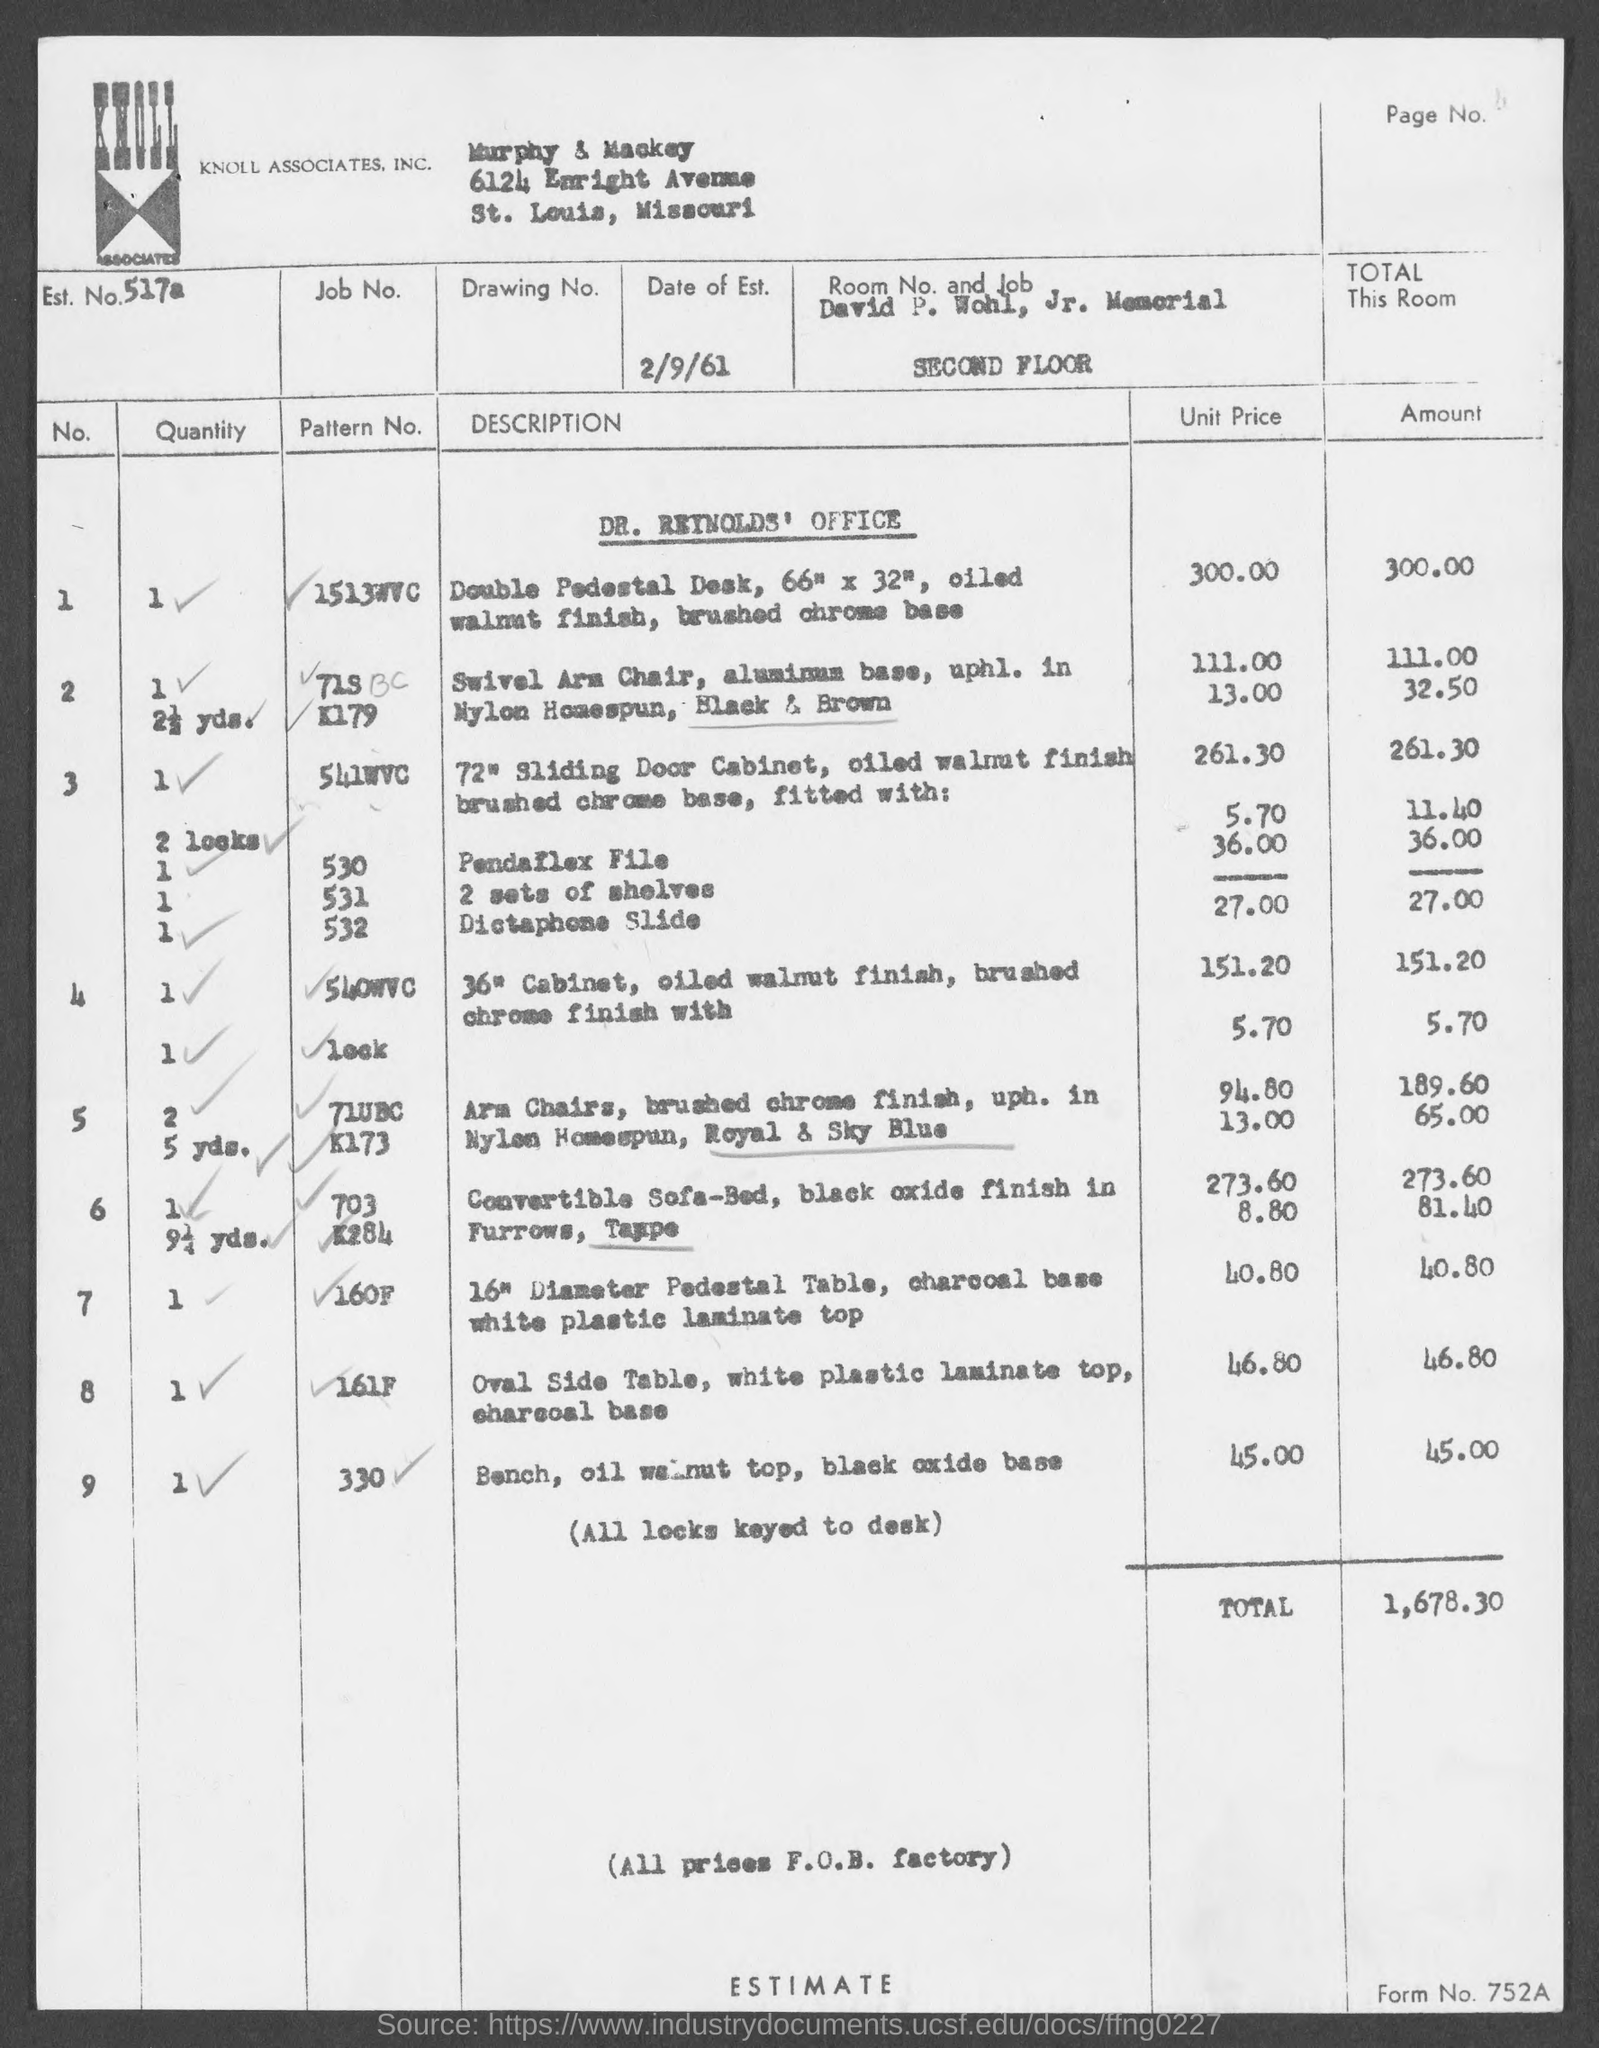List a handful of essential elements in this visual. The date of establishment mentioned in the document is 2/9/61. The estimated number provided in the document is 517a.. The estimated total amount for Dr. Reynolds' Office is 1,678.30. 